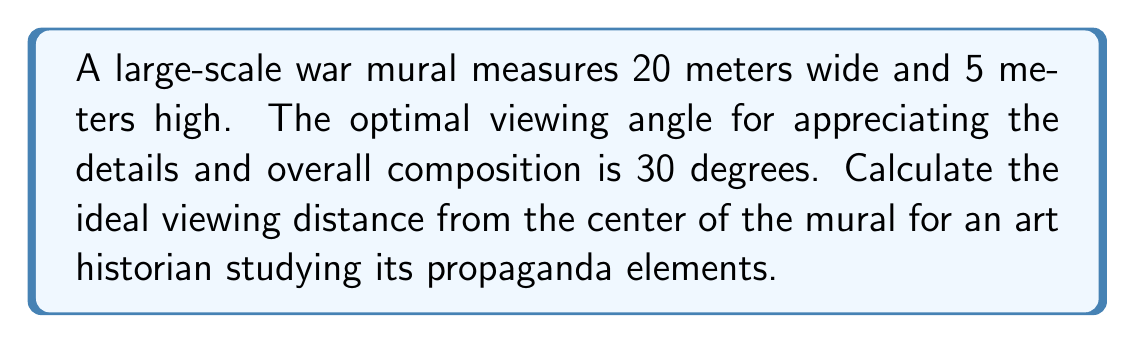Could you help me with this problem? To determine the optimal viewing distance, we'll follow these steps:

1) First, we need to consider the vertical field of view. The optimal viewing angle of 30 degrees should encompass the entire height of the mural.

2) We can use the tangent function to relate the height of the mural to the viewing distance:

   $$\tan(\frac{\theta}{2}) = \frac{\text{half height of mural}}{\text{viewing distance}}$$

3) We know that $\theta = 30°$ and the height of the mural is 5 meters. Let's call the viewing distance $d$. Substituting these values:

   $$\tan(15°) = \frac{2.5}{d}$$

4) Now we can solve for $d$:

   $$d = \frac{2.5}{\tan(15°)}$$

5) Using a calculator or programming language to evaluate this:

   $$d \approx 9.33 \text{ meters}$$

6) To verify, we can check if this distance also works well for the width of the mural. The horizontal viewing angle at this distance would be:

   $$2 \cdot \arctan(\frac{10}{9.33}) \approx 94.9°$$

   This is a reasonable angle for taking in the entire width of the mural.

Therefore, the optimal viewing distance for an art historian to study this war mural is approximately 9.33 meters from the center of the mural.
Answer: 9.33 meters 